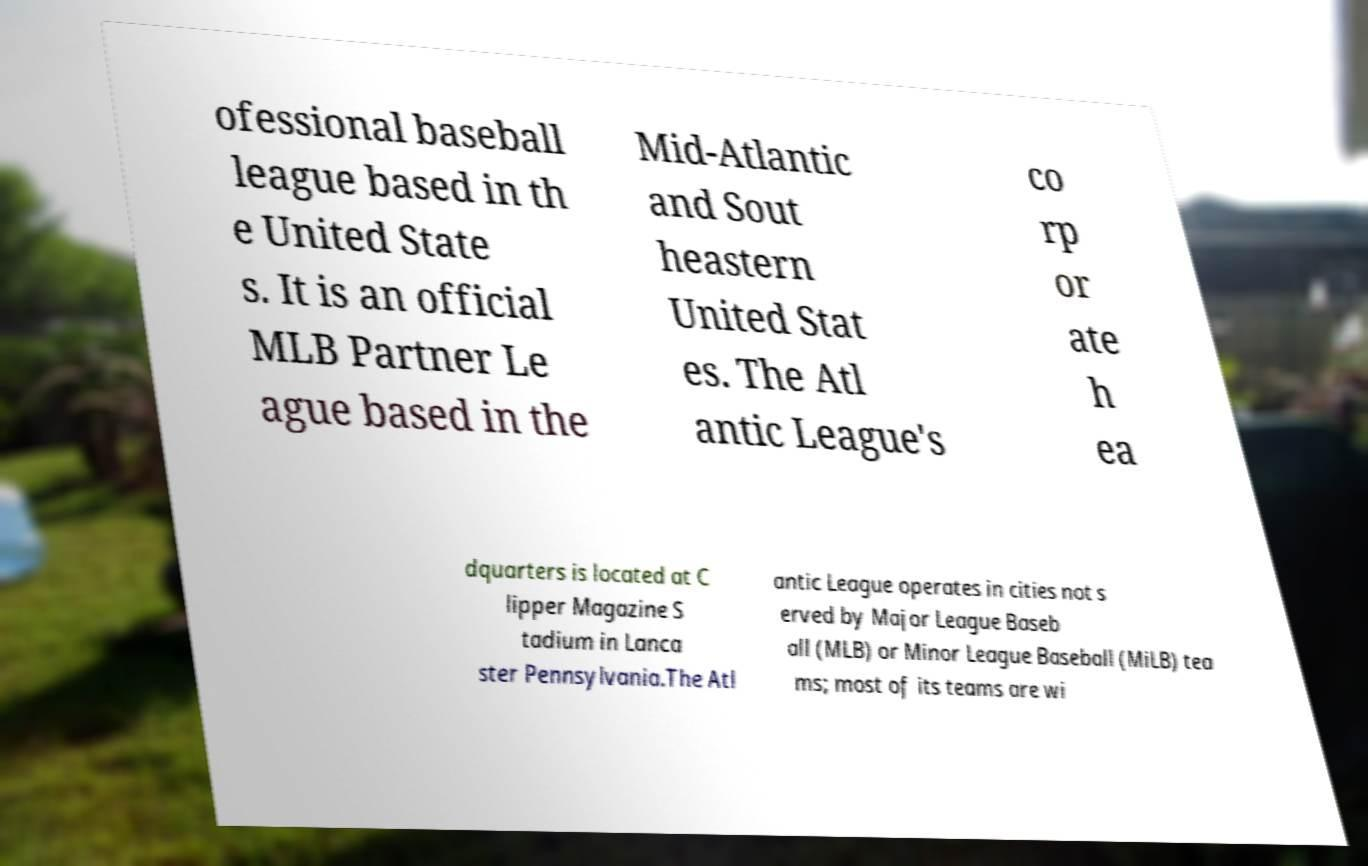Please identify and transcribe the text found in this image. ofessional baseball league based in th e United State s. It is an official MLB Partner Le ague based in the Mid-Atlantic and Sout heastern United Stat es. The Atl antic League's co rp or ate h ea dquarters is located at C lipper Magazine S tadium in Lanca ster Pennsylvania.The Atl antic League operates in cities not s erved by Major League Baseb all (MLB) or Minor League Baseball (MiLB) tea ms; most of its teams are wi 